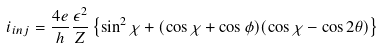<formula> <loc_0><loc_0><loc_500><loc_500>i _ { i n j } = \frac { 4 e } { h } \frac { \epsilon ^ { 2 } } { Z } \left \{ \sin ^ { 2 } \chi + ( \cos \chi + \cos \phi ) ( \cos \chi - \cos 2 \theta ) \right \}</formula> 